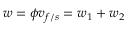Convert formula to latex. <formula><loc_0><loc_0><loc_500><loc_500>w = \phi v _ { f / s } = w _ { 1 } + w _ { 2 }</formula> 